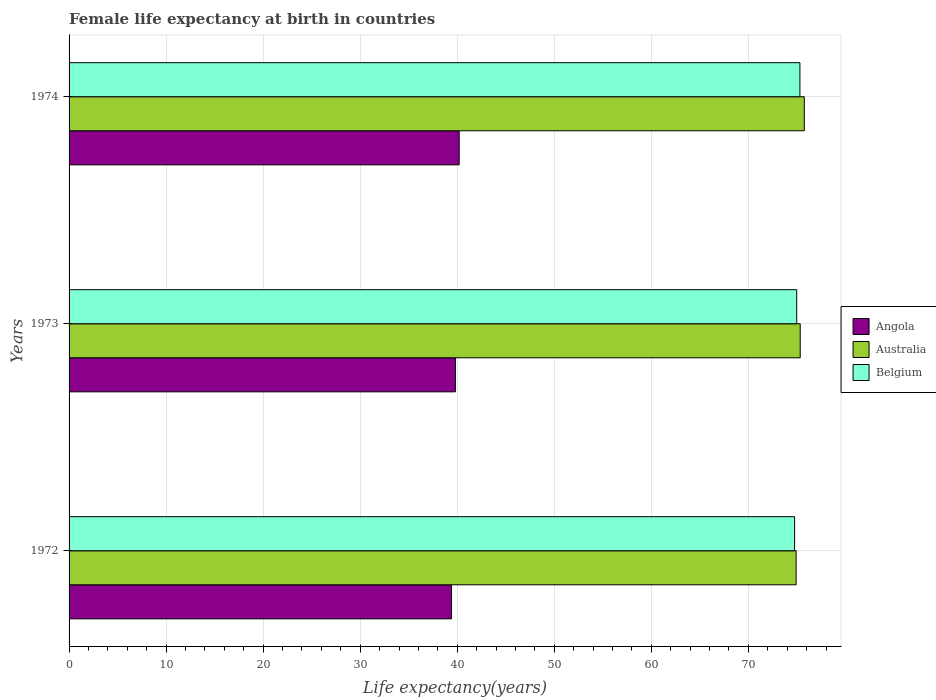How many groups of bars are there?
Offer a very short reply. 3. How many bars are there on the 1st tick from the top?
Give a very brief answer. 3. What is the female life expectancy at birth in Australia in 1974?
Give a very brief answer. 75.76. Across all years, what is the maximum female life expectancy at birth in Australia?
Your response must be concise. 75.76. Across all years, what is the minimum female life expectancy at birth in Australia?
Your response must be concise. 74.92. In which year was the female life expectancy at birth in Angola maximum?
Make the answer very short. 1974. In which year was the female life expectancy at birth in Australia minimum?
Offer a terse response. 1972. What is the total female life expectancy at birth in Angola in the graph?
Your answer should be compact. 119.41. What is the difference between the female life expectancy at birth in Belgium in 1973 and that in 1974?
Make the answer very short. -0.33. What is the difference between the female life expectancy at birth in Belgium in 1973 and the female life expectancy at birth in Australia in 1974?
Ensure brevity in your answer.  -0.78. What is the average female life expectancy at birth in Australia per year?
Ensure brevity in your answer.  75.34. In the year 1973, what is the difference between the female life expectancy at birth in Angola and female life expectancy at birth in Belgium?
Keep it short and to the point. -35.17. In how many years, is the female life expectancy at birth in Australia greater than 26 years?
Give a very brief answer. 3. What is the ratio of the female life expectancy at birth in Belgium in 1973 to that in 1974?
Your answer should be compact. 1. Is the difference between the female life expectancy at birth in Angola in 1972 and 1973 greater than the difference between the female life expectancy at birth in Belgium in 1972 and 1973?
Give a very brief answer. No. What is the difference between the highest and the second highest female life expectancy at birth in Belgium?
Your answer should be compact. 0.33. What is the difference between the highest and the lowest female life expectancy at birth in Belgium?
Your answer should be very brief. 0.55. What does the 1st bar from the bottom in 1972 represents?
Your answer should be compact. Angola. Is it the case that in every year, the sum of the female life expectancy at birth in Angola and female life expectancy at birth in Belgium is greater than the female life expectancy at birth in Australia?
Provide a succinct answer. Yes. Does the graph contain any zero values?
Offer a very short reply. No. Does the graph contain grids?
Give a very brief answer. Yes. Where does the legend appear in the graph?
Offer a terse response. Center right. What is the title of the graph?
Offer a terse response. Female life expectancy at birth in countries. Does "South Asia" appear as one of the legend labels in the graph?
Your answer should be very brief. No. What is the label or title of the X-axis?
Keep it short and to the point. Life expectancy(years). What is the Life expectancy(years) in Angola in 1972?
Offer a terse response. 39.41. What is the Life expectancy(years) in Australia in 1972?
Your answer should be compact. 74.92. What is the Life expectancy(years) of Belgium in 1972?
Your answer should be very brief. 74.76. What is the Life expectancy(years) in Angola in 1973?
Offer a terse response. 39.81. What is the Life expectancy(years) in Australia in 1973?
Provide a succinct answer. 75.34. What is the Life expectancy(years) of Belgium in 1973?
Provide a short and direct response. 74.98. What is the Life expectancy(years) in Angola in 1974?
Provide a short and direct response. 40.2. What is the Life expectancy(years) in Australia in 1974?
Keep it short and to the point. 75.76. What is the Life expectancy(years) of Belgium in 1974?
Your answer should be very brief. 75.31. Across all years, what is the maximum Life expectancy(years) of Angola?
Offer a terse response. 40.2. Across all years, what is the maximum Life expectancy(years) of Australia?
Your answer should be very brief. 75.76. Across all years, what is the maximum Life expectancy(years) in Belgium?
Give a very brief answer. 75.31. Across all years, what is the minimum Life expectancy(years) in Angola?
Make the answer very short. 39.41. Across all years, what is the minimum Life expectancy(years) of Australia?
Give a very brief answer. 74.92. Across all years, what is the minimum Life expectancy(years) in Belgium?
Offer a very short reply. 74.76. What is the total Life expectancy(years) of Angola in the graph?
Your answer should be compact. 119.41. What is the total Life expectancy(years) of Australia in the graph?
Provide a succinct answer. 226.02. What is the total Life expectancy(years) of Belgium in the graph?
Ensure brevity in your answer.  225.05. What is the difference between the Life expectancy(years) of Angola in 1972 and that in 1973?
Give a very brief answer. -0.4. What is the difference between the Life expectancy(years) of Australia in 1972 and that in 1973?
Your answer should be compact. -0.42. What is the difference between the Life expectancy(years) in Belgium in 1972 and that in 1973?
Give a very brief answer. -0.22. What is the difference between the Life expectancy(years) of Angola in 1972 and that in 1974?
Provide a short and direct response. -0.79. What is the difference between the Life expectancy(years) in Australia in 1972 and that in 1974?
Make the answer very short. -0.84. What is the difference between the Life expectancy(years) of Belgium in 1972 and that in 1974?
Give a very brief answer. -0.55. What is the difference between the Life expectancy(years) of Angola in 1973 and that in 1974?
Provide a short and direct response. -0.39. What is the difference between the Life expectancy(years) in Australia in 1973 and that in 1974?
Make the answer very short. -0.42. What is the difference between the Life expectancy(years) of Belgium in 1973 and that in 1974?
Your answer should be compact. -0.33. What is the difference between the Life expectancy(years) of Angola in 1972 and the Life expectancy(years) of Australia in 1973?
Provide a succinct answer. -35.94. What is the difference between the Life expectancy(years) of Angola in 1972 and the Life expectancy(years) of Belgium in 1973?
Your answer should be very brief. -35.58. What is the difference between the Life expectancy(years) of Australia in 1972 and the Life expectancy(years) of Belgium in 1973?
Provide a short and direct response. -0.06. What is the difference between the Life expectancy(years) of Angola in 1972 and the Life expectancy(years) of Australia in 1974?
Your response must be concise. -36.35. What is the difference between the Life expectancy(years) in Angola in 1972 and the Life expectancy(years) in Belgium in 1974?
Offer a very short reply. -35.91. What is the difference between the Life expectancy(years) in Australia in 1972 and the Life expectancy(years) in Belgium in 1974?
Offer a terse response. -0.39. What is the difference between the Life expectancy(years) of Angola in 1973 and the Life expectancy(years) of Australia in 1974?
Give a very brief answer. -35.95. What is the difference between the Life expectancy(years) in Angola in 1973 and the Life expectancy(years) in Belgium in 1974?
Your response must be concise. -35.5. What is the average Life expectancy(years) in Angola per year?
Your answer should be very brief. 39.8. What is the average Life expectancy(years) of Australia per year?
Offer a very short reply. 75.34. What is the average Life expectancy(years) in Belgium per year?
Ensure brevity in your answer.  75.02. In the year 1972, what is the difference between the Life expectancy(years) of Angola and Life expectancy(years) of Australia?
Your response must be concise. -35.52. In the year 1972, what is the difference between the Life expectancy(years) of Angola and Life expectancy(years) of Belgium?
Your response must be concise. -35.35. In the year 1972, what is the difference between the Life expectancy(years) in Australia and Life expectancy(years) in Belgium?
Provide a short and direct response. 0.16. In the year 1973, what is the difference between the Life expectancy(years) of Angola and Life expectancy(years) of Australia?
Offer a terse response. -35.53. In the year 1973, what is the difference between the Life expectancy(years) of Angola and Life expectancy(years) of Belgium?
Make the answer very short. -35.17. In the year 1973, what is the difference between the Life expectancy(years) of Australia and Life expectancy(years) of Belgium?
Provide a succinct answer. 0.36. In the year 1974, what is the difference between the Life expectancy(years) in Angola and Life expectancy(years) in Australia?
Provide a short and direct response. -35.56. In the year 1974, what is the difference between the Life expectancy(years) of Angola and Life expectancy(years) of Belgium?
Give a very brief answer. -35.11. In the year 1974, what is the difference between the Life expectancy(years) in Australia and Life expectancy(years) in Belgium?
Give a very brief answer. 0.45. What is the ratio of the Life expectancy(years) of Australia in 1972 to that in 1973?
Give a very brief answer. 0.99. What is the ratio of the Life expectancy(years) in Angola in 1972 to that in 1974?
Your answer should be very brief. 0.98. What is the ratio of the Life expectancy(years) in Australia in 1972 to that in 1974?
Ensure brevity in your answer.  0.99. What is the ratio of the Life expectancy(years) of Belgium in 1972 to that in 1974?
Make the answer very short. 0.99. What is the ratio of the Life expectancy(years) of Angola in 1973 to that in 1974?
Provide a short and direct response. 0.99. What is the ratio of the Life expectancy(years) of Belgium in 1973 to that in 1974?
Your answer should be compact. 1. What is the difference between the highest and the second highest Life expectancy(years) of Angola?
Give a very brief answer. 0.39. What is the difference between the highest and the second highest Life expectancy(years) of Australia?
Provide a short and direct response. 0.42. What is the difference between the highest and the second highest Life expectancy(years) in Belgium?
Ensure brevity in your answer.  0.33. What is the difference between the highest and the lowest Life expectancy(years) of Angola?
Give a very brief answer. 0.79. What is the difference between the highest and the lowest Life expectancy(years) of Australia?
Make the answer very short. 0.84. What is the difference between the highest and the lowest Life expectancy(years) in Belgium?
Ensure brevity in your answer.  0.55. 